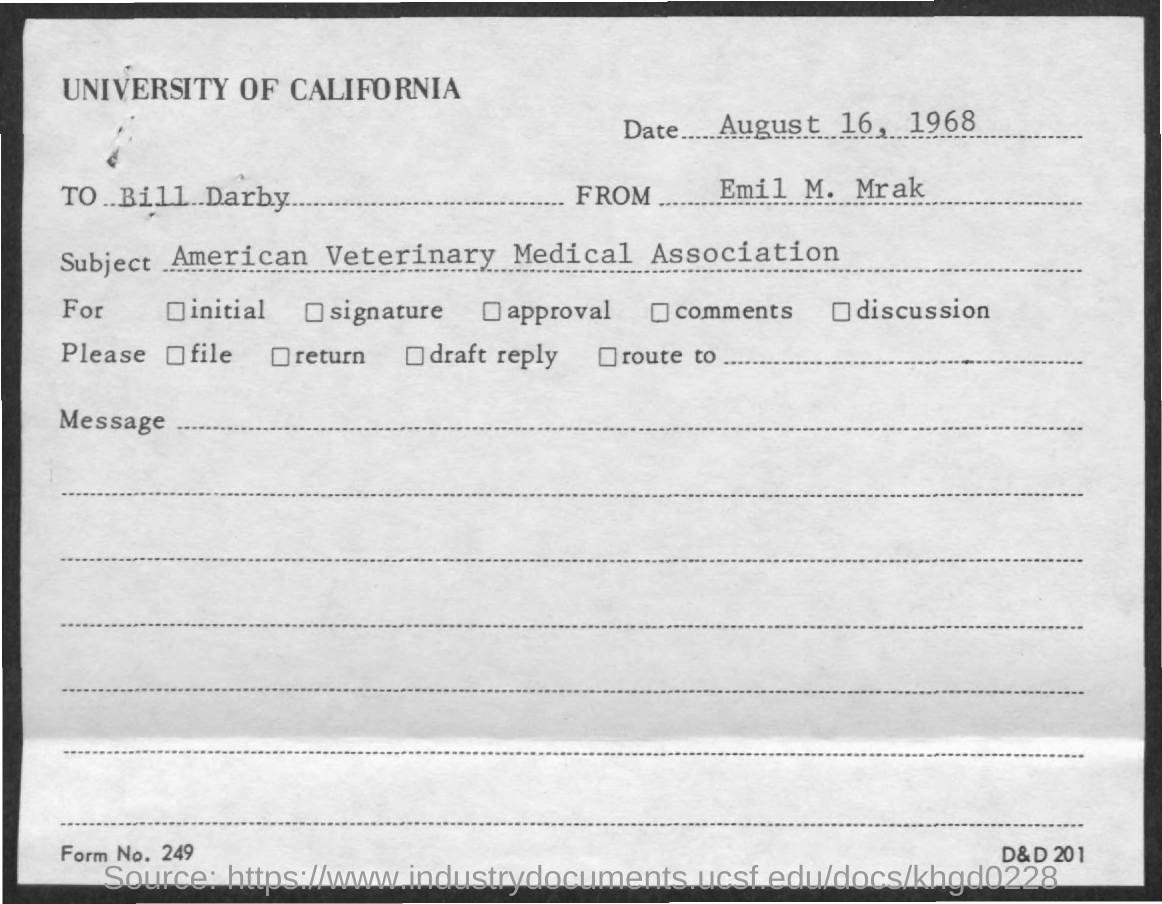Give some essential details in this illustration. The memorandum is from Emil M. Mrak. What is Form Number 249? The memorandum is addressed to Bill Darby. The memorandum was dated on August 16, 1968. 